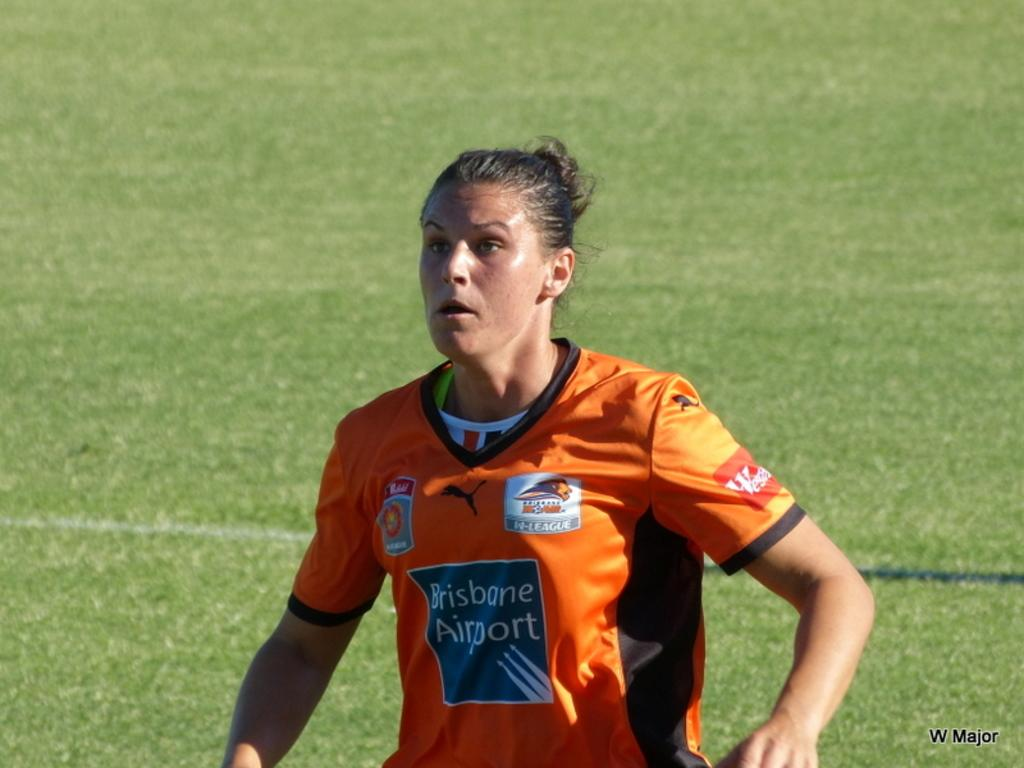Provide a one-sentence caption for the provided image. A woman is on a sports field with a jersey reading Brisbane Airport. 